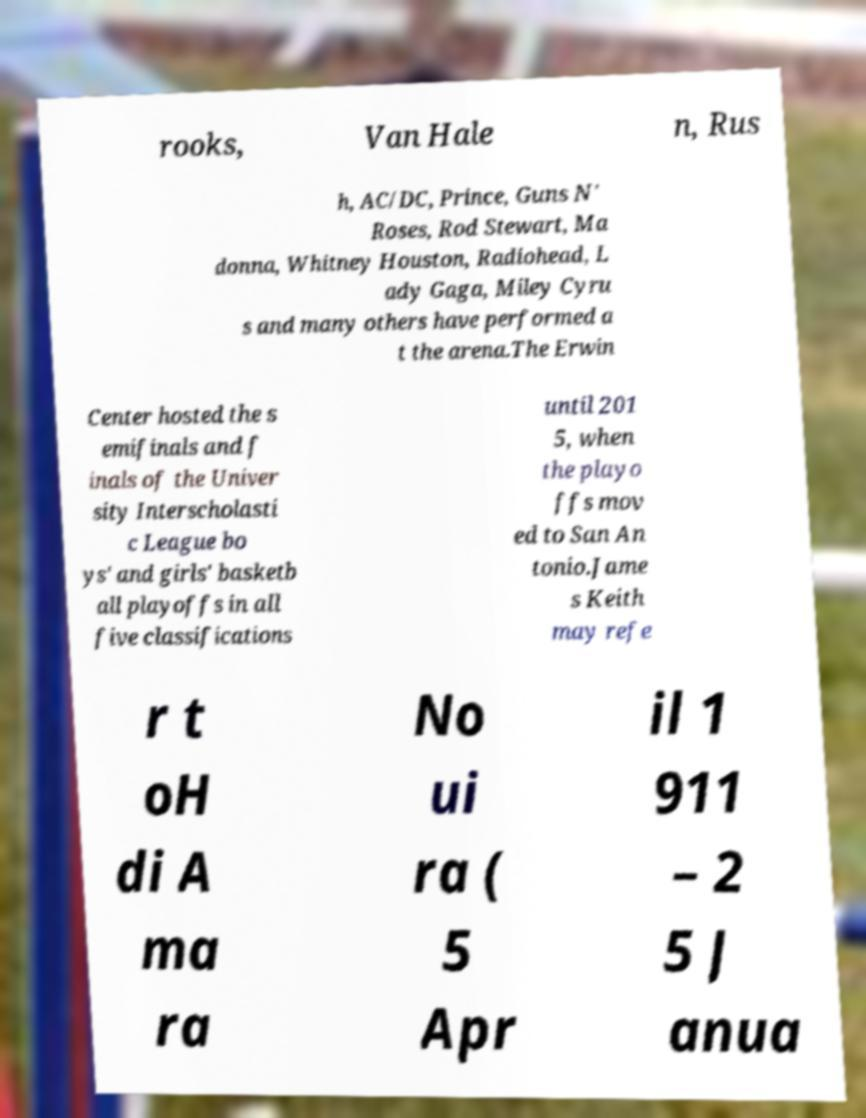Please identify and transcribe the text found in this image. rooks, Van Hale n, Rus h, AC/DC, Prince, Guns N' Roses, Rod Stewart, Ma donna, Whitney Houston, Radiohead, L ady Gaga, Miley Cyru s and many others have performed a t the arena.The Erwin Center hosted the s emifinals and f inals of the Univer sity Interscholasti c League bo ys' and girls' basketb all playoffs in all five classifications until 201 5, when the playo ffs mov ed to San An tonio.Jame s Keith may refe r t oH di A ma ra No ui ra ( 5 Apr il 1 911 – 2 5 J anua 